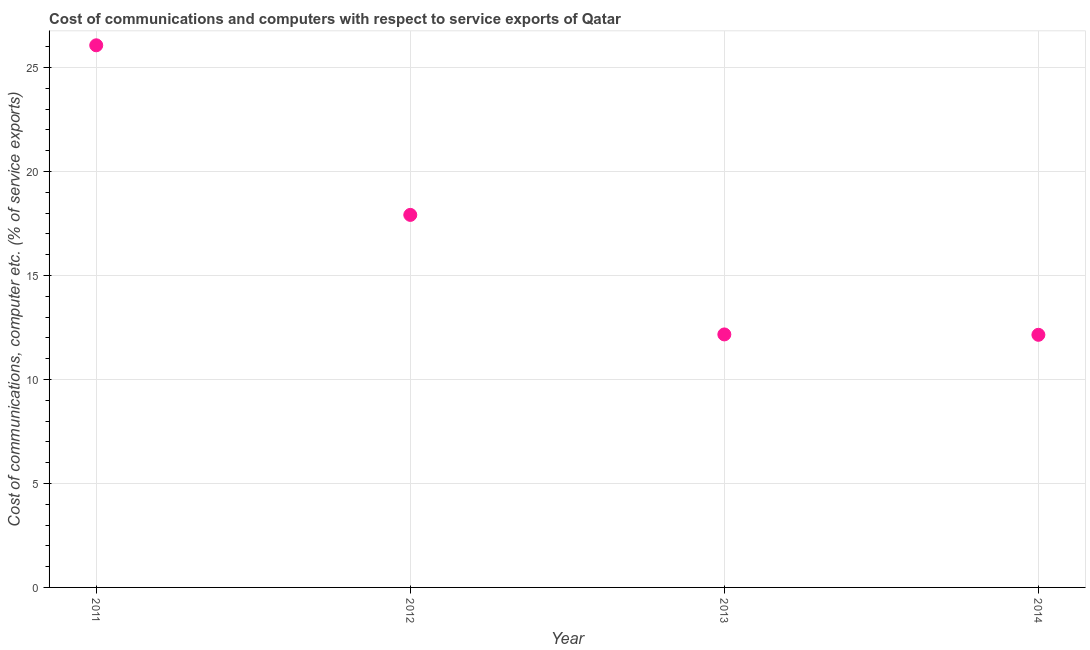What is the cost of communications and computer in 2012?
Keep it short and to the point. 17.91. Across all years, what is the maximum cost of communications and computer?
Keep it short and to the point. 26.07. Across all years, what is the minimum cost of communications and computer?
Your response must be concise. 12.15. In which year was the cost of communications and computer minimum?
Provide a short and direct response. 2014. What is the sum of the cost of communications and computer?
Give a very brief answer. 68.3. What is the difference between the cost of communications and computer in 2012 and 2014?
Offer a very short reply. 5.77. What is the average cost of communications and computer per year?
Your response must be concise. 17.07. What is the median cost of communications and computer?
Ensure brevity in your answer.  15.04. In how many years, is the cost of communications and computer greater than 4 %?
Provide a short and direct response. 4. What is the ratio of the cost of communications and computer in 2012 to that in 2014?
Offer a terse response. 1.47. Is the cost of communications and computer in 2011 less than that in 2013?
Keep it short and to the point. No. What is the difference between the highest and the second highest cost of communications and computer?
Your response must be concise. 8.16. Is the sum of the cost of communications and computer in 2011 and 2013 greater than the maximum cost of communications and computer across all years?
Give a very brief answer. Yes. What is the difference between the highest and the lowest cost of communications and computer?
Your response must be concise. 13.92. In how many years, is the cost of communications and computer greater than the average cost of communications and computer taken over all years?
Keep it short and to the point. 2. Does the cost of communications and computer monotonically increase over the years?
Offer a terse response. No. How many years are there in the graph?
Provide a succinct answer. 4. What is the difference between two consecutive major ticks on the Y-axis?
Offer a terse response. 5. Are the values on the major ticks of Y-axis written in scientific E-notation?
Provide a succinct answer. No. Does the graph contain any zero values?
Provide a succinct answer. No. Does the graph contain grids?
Provide a short and direct response. Yes. What is the title of the graph?
Give a very brief answer. Cost of communications and computers with respect to service exports of Qatar. What is the label or title of the X-axis?
Provide a succinct answer. Year. What is the label or title of the Y-axis?
Offer a terse response. Cost of communications, computer etc. (% of service exports). What is the Cost of communications, computer etc. (% of service exports) in 2011?
Your answer should be very brief. 26.07. What is the Cost of communications, computer etc. (% of service exports) in 2012?
Offer a terse response. 17.91. What is the Cost of communications, computer etc. (% of service exports) in 2013?
Provide a succinct answer. 12.17. What is the Cost of communications, computer etc. (% of service exports) in 2014?
Your answer should be very brief. 12.15. What is the difference between the Cost of communications, computer etc. (% of service exports) in 2011 and 2012?
Give a very brief answer. 8.16. What is the difference between the Cost of communications, computer etc. (% of service exports) in 2011 and 2013?
Give a very brief answer. 13.9. What is the difference between the Cost of communications, computer etc. (% of service exports) in 2011 and 2014?
Provide a short and direct response. 13.92. What is the difference between the Cost of communications, computer etc. (% of service exports) in 2012 and 2013?
Ensure brevity in your answer.  5.75. What is the difference between the Cost of communications, computer etc. (% of service exports) in 2012 and 2014?
Your answer should be very brief. 5.77. What is the difference between the Cost of communications, computer etc. (% of service exports) in 2013 and 2014?
Ensure brevity in your answer.  0.02. What is the ratio of the Cost of communications, computer etc. (% of service exports) in 2011 to that in 2012?
Offer a very short reply. 1.46. What is the ratio of the Cost of communications, computer etc. (% of service exports) in 2011 to that in 2013?
Offer a terse response. 2.14. What is the ratio of the Cost of communications, computer etc. (% of service exports) in 2011 to that in 2014?
Provide a short and direct response. 2.15. What is the ratio of the Cost of communications, computer etc. (% of service exports) in 2012 to that in 2013?
Keep it short and to the point. 1.47. What is the ratio of the Cost of communications, computer etc. (% of service exports) in 2012 to that in 2014?
Provide a succinct answer. 1.48. What is the ratio of the Cost of communications, computer etc. (% of service exports) in 2013 to that in 2014?
Offer a very short reply. 1. 